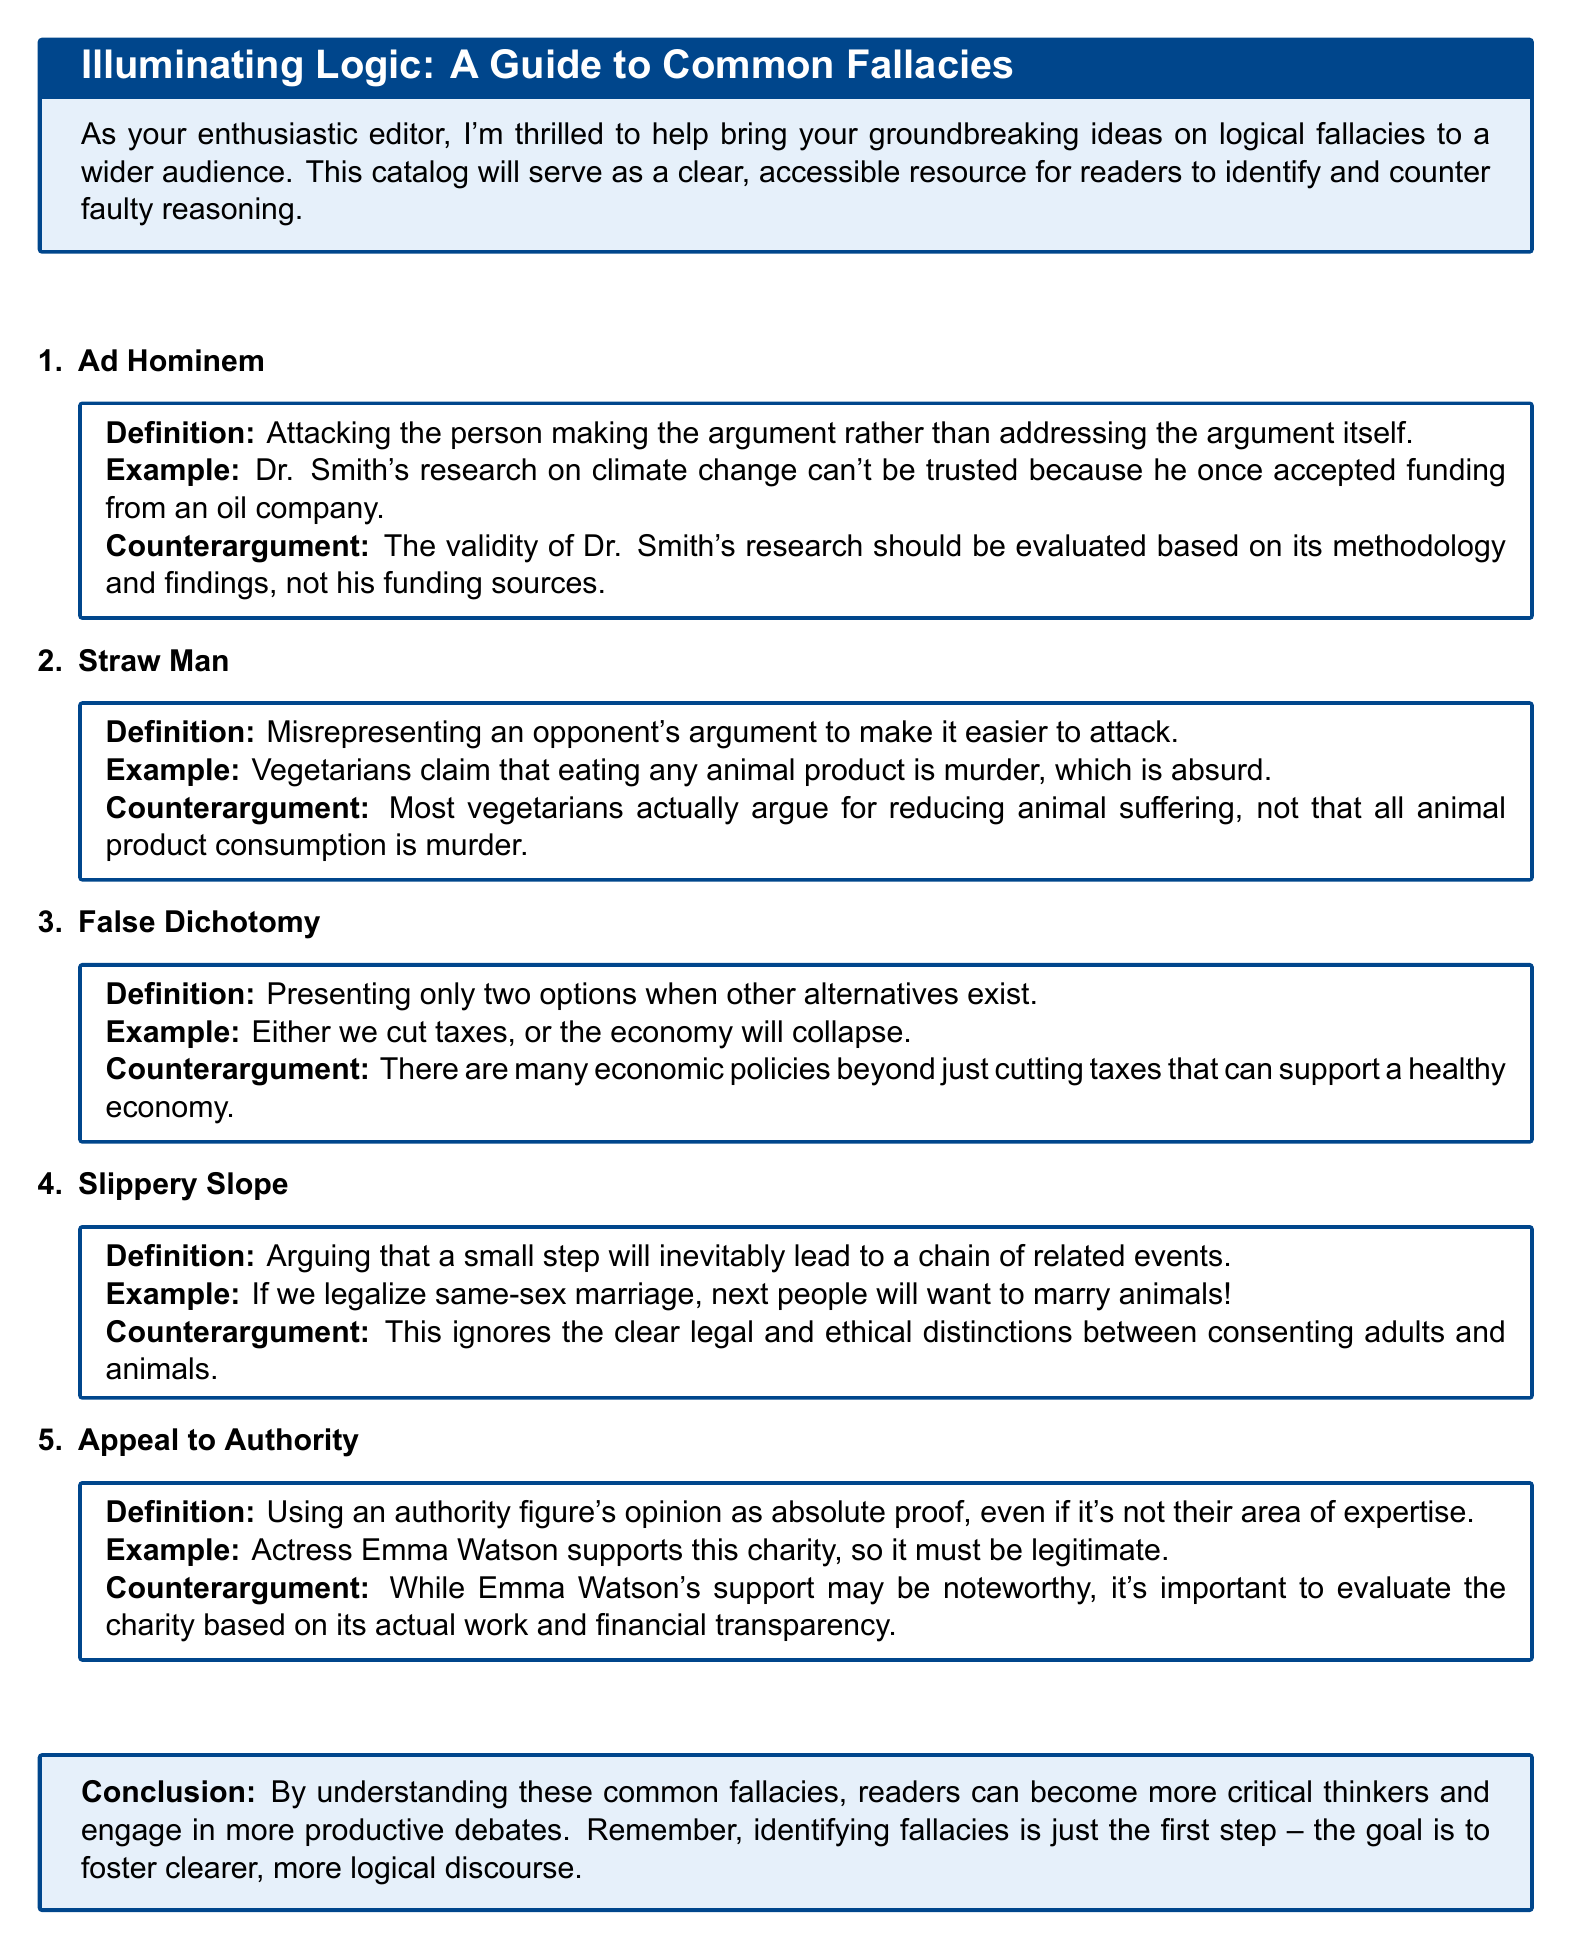What is the title of the document? The title of the document is presented in the introductory box at the top of the document.
Answer: Illuminating Logic: A Guide to Common Fallacies How many logical fallacies are listed? The number of logical fallacies can be counted from the enumerated list provided in the document.
Answer: 5 What is an example of an Ad Hominem fallacy? The example for Ad Hominem is presented immediately after the definition in the corresponding box.
Answer: Dr. Smith's research on climate change can't be trusted because he once accepted funding from an oil company What is the counterargument for the Straw Man fallacy? The counterargument is provided right after the example of the Straw Man fallacy in its dedicated box.
Answer: Most vegetarians actually argue for reducing animal suffering, not that all animal product consumption is murder What color is the background of the tcolorbox? The color of the tcolorbox background is specified in the document using a color definition.
Answer: mylightblue What is the definition of False Dichotomy? The definition can be found in the corresponding tcolorbox under the False Dichotomy section.
Answer: Presenting only two options when other alternatives exist What logical fallacy does the example "If we legalize same-sex marriage, next people will want to marry animals!" illustrate? The example illustrates a specific type of fallacy listed in the document.
Answer: Slippery Slope What is the purpose of the catalog according to the conclusion? The purpose is summarized in the concluding remarks, which encapsulate the main goal of the document.
Answer: Foster clearer, more logical discourse 